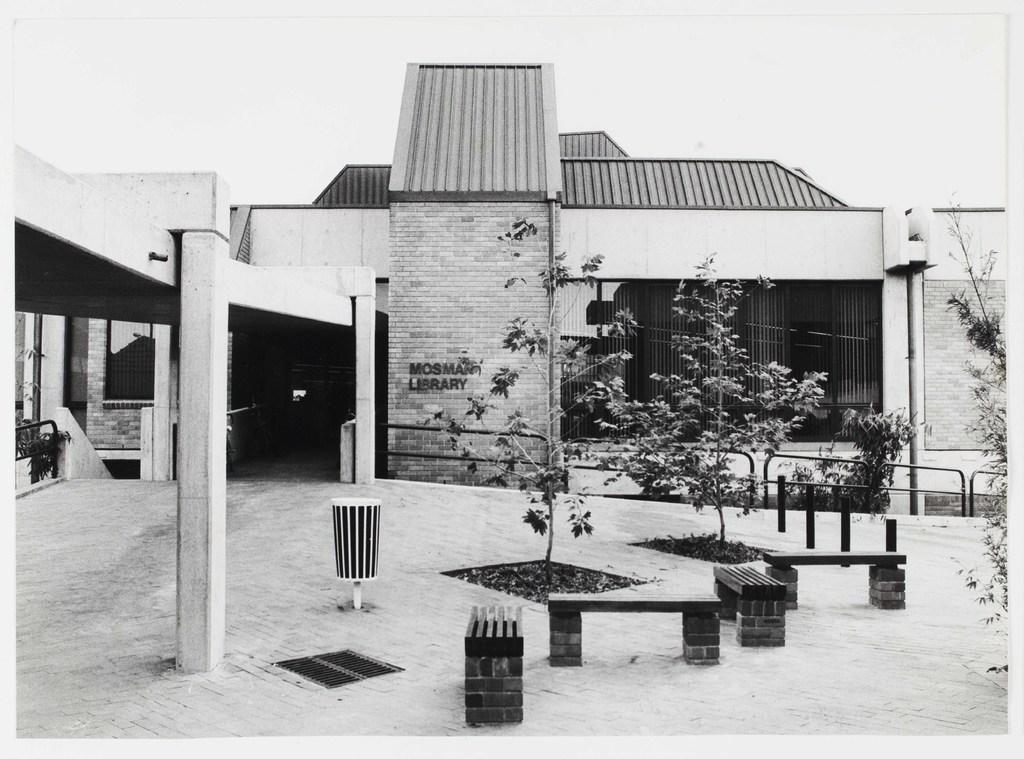Can you describe this image briefly? In this image in the background there is building. In the foreground there are benches, trees. Here there is boundary. A dustbin is there. The sky is clear. 